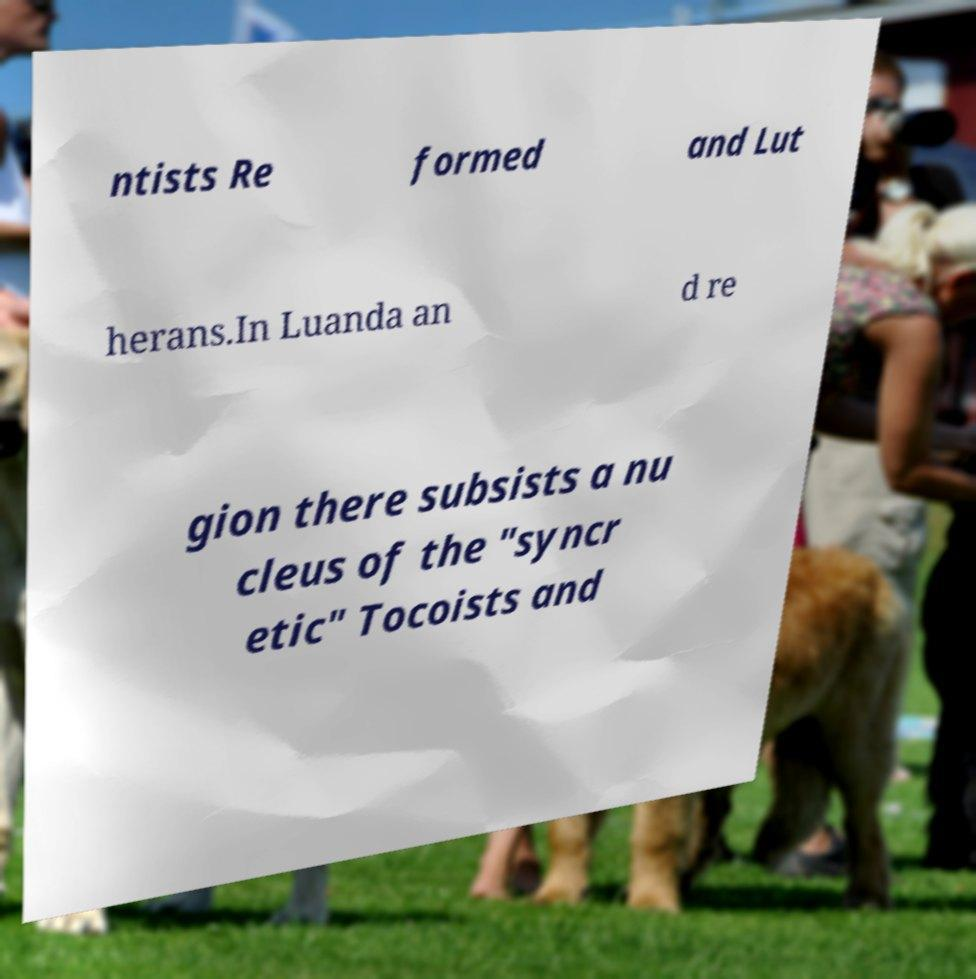Could you assist in decoding the text presented in this image and type it out clearly? ntists Re formed and Lut herans.In Luanda an d re gion there subsists a nu cleus of the "syncr etic" Tocoists and 